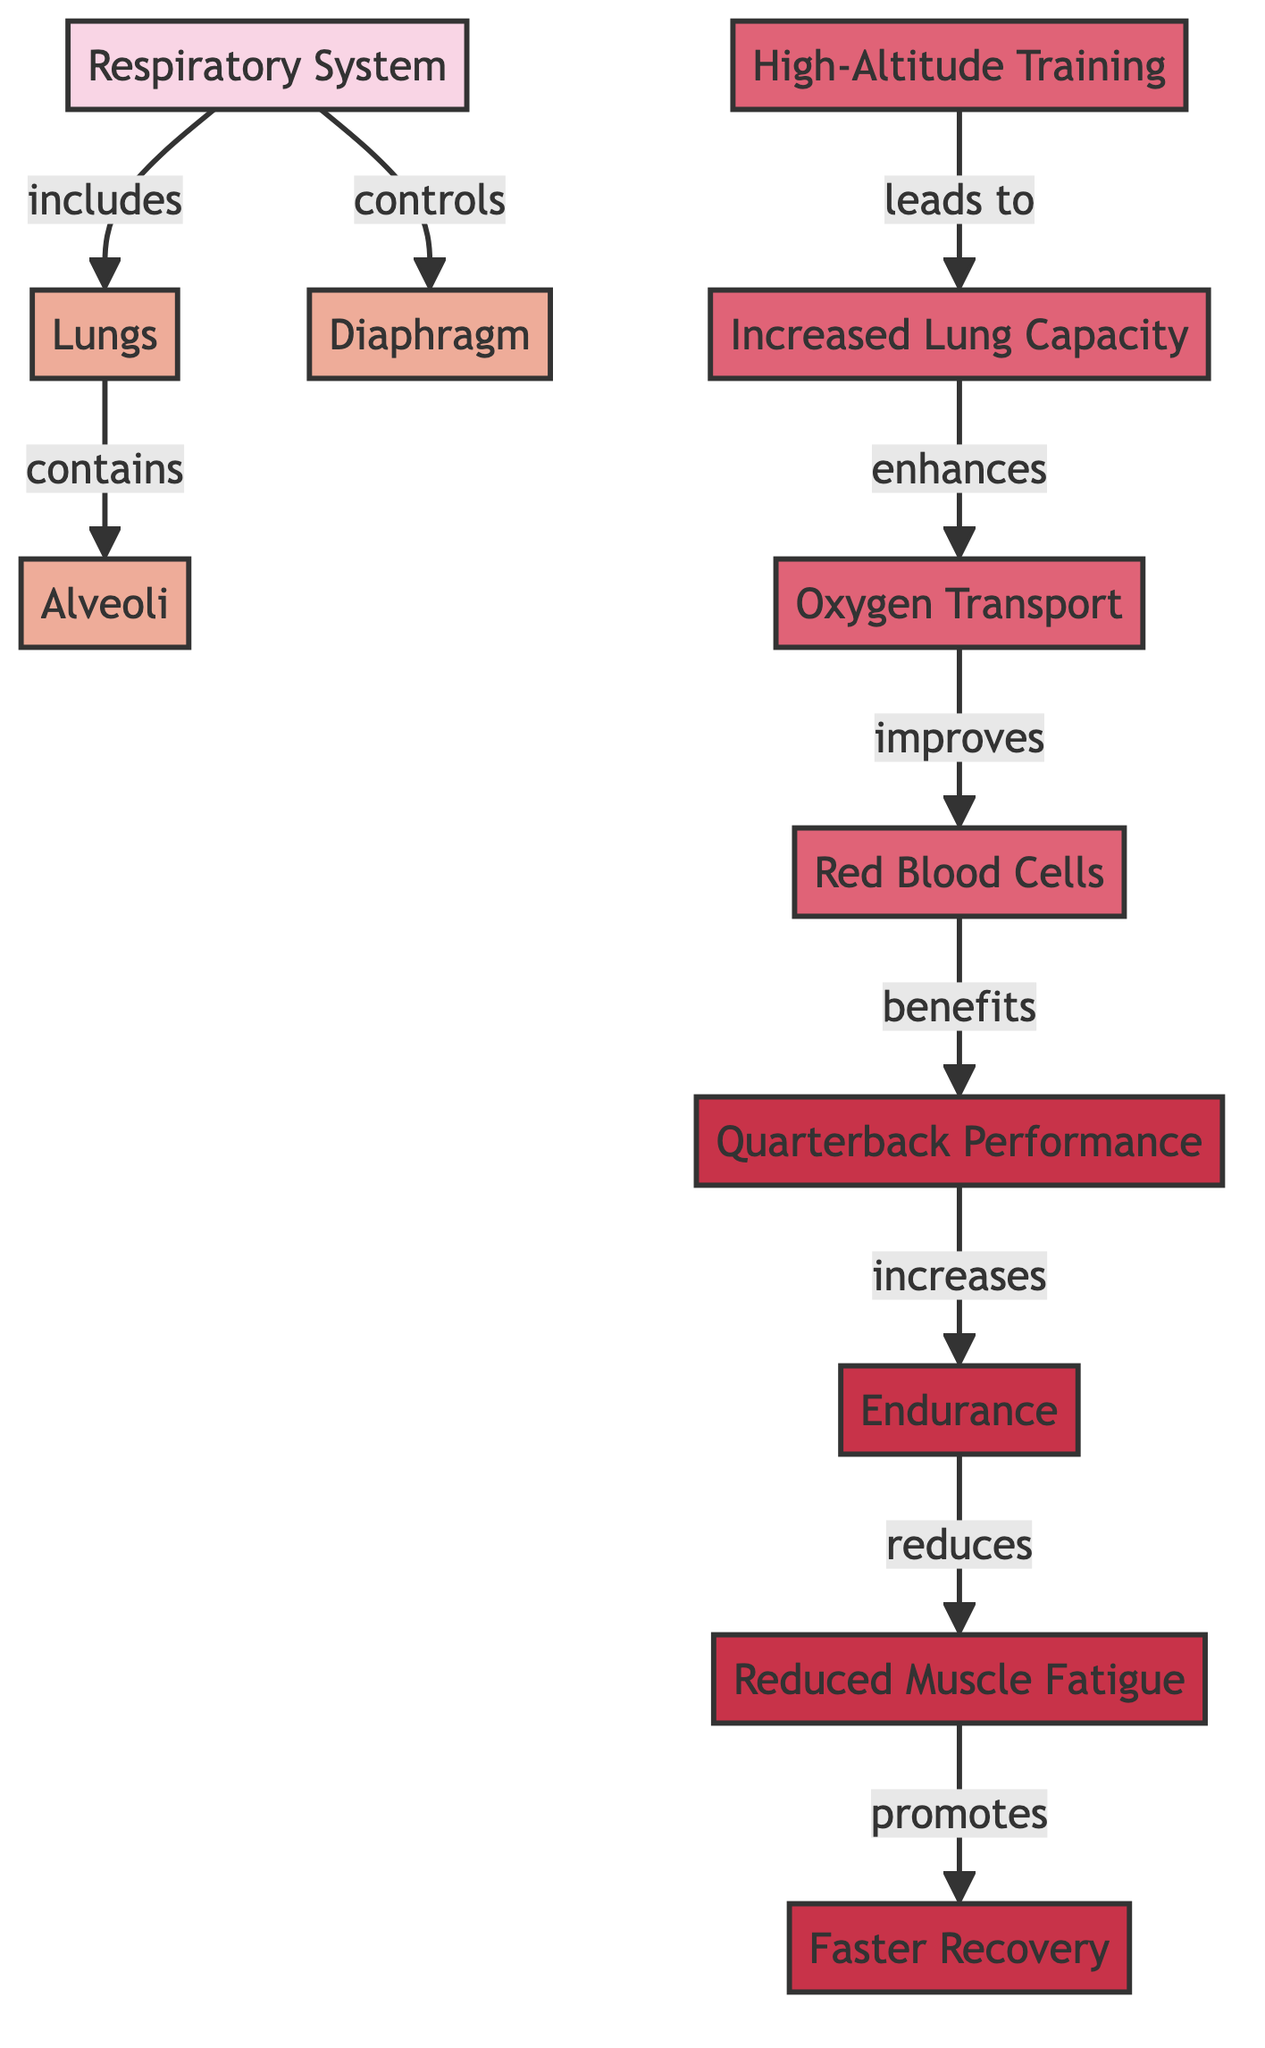What are the main components of the respiratory system? The diagram includes three main components related to the respiratory system: lungs, alveoli, and diaphragm. These components are connected and represent the structure and function of the respiratory system as shown in the diagram.
Answer: lungs, alveoli, diaphragm How does high-altitude training impact lung capacity? According to the flow in the diagram, high-altitude training directly leads to increased lung capacity. This connection shows that engaging in high-altitude training improves lung function, crucial for enhancing performance in quarterbacks.
Answer: increased lung capacity What physiological process benefits from increased lung capacity? The diagram indicates that increased lung capacity enhances the oxygen transport process. By seeing this link, we can deduce that more effective oxygen transport is a direct outcome of improved lung capacity.
Answer: oxygen transport What are the performance benefits listed for quarterbacks? The diagram outlines several performance benefits for quarterbacks, including increased endurance, reduced muscle fatigue, and faster recovery. Each of these benefits follows a logical flow from improved oxygen transport underlined by high-altitude training effects.
Answer: increased endurance, reduced muscle fatigue, faster recovery How does improved oxygen transport influence quarterback performance? The relationship shown in the diagram highlights that improved oxygen transport leads to benefits for quarterback performance. This means that better oxygen circulation enhances the physical output and efficiency of players during a game.
Answer: quarterback performance What role do red blood cells play in the diagram? The diagram illustrates that red blood cells benefit from improved oxygen transport, which is a result of increased lung capacity influenced by high-altitude training. This demonstrates the critical role red blood cells play in ensuring adequate oxygen delivery, vital for athletic performance.
Answer: red blood cells What is the connection between muscle fatigue and endurance in quarterbacks? The flow in the diagram shows that increased endurance reduces muscle fatigue. This is a significant link as it suggests that enhanced physical stamina contributes to minimizing tiredness during games, leading to better overall performance.
Answer: reduced muscle fatigue How many total nodes are present in the diagram? By counting the distinct components shown in the diagram, there are eleven nodes representing various parts of the respiratory system, training aspects, and performance results.
Answer: eleven What is the importance of the diaphragm in the respiratory system? The diagram indicates that the diaphragm plays a controlling role in the respiratory system. It is crucial for normal breathing and optimizes the efficiency of the lungs as part of the respiratory process.
Answer: controls What is the overall goal of high-altitude training for quarterbacks? The diagram suggests that the overall goal of high-altitude training for quarterbacks is to enhance their performance by improving endurance, reducing fatigue, and speeding up recovery, ultimately benefiting their gameplay.
Answer: enhance performance 